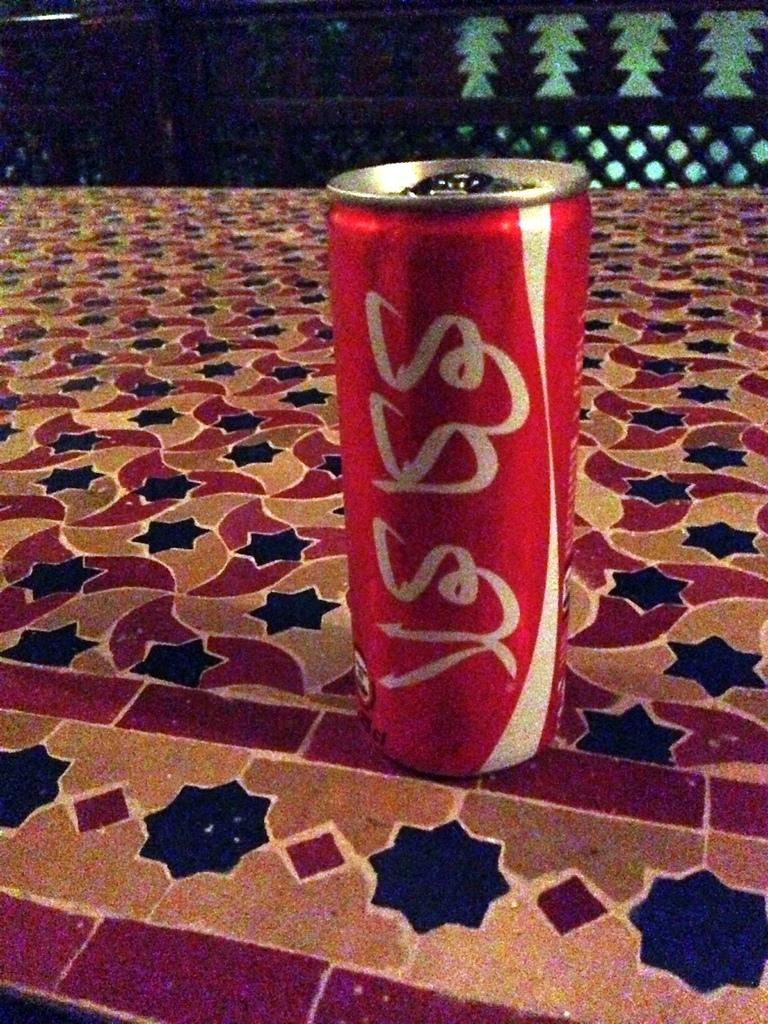Provide a one-sentence caption for the provided image. A can of coke placed on some colorful tile. 